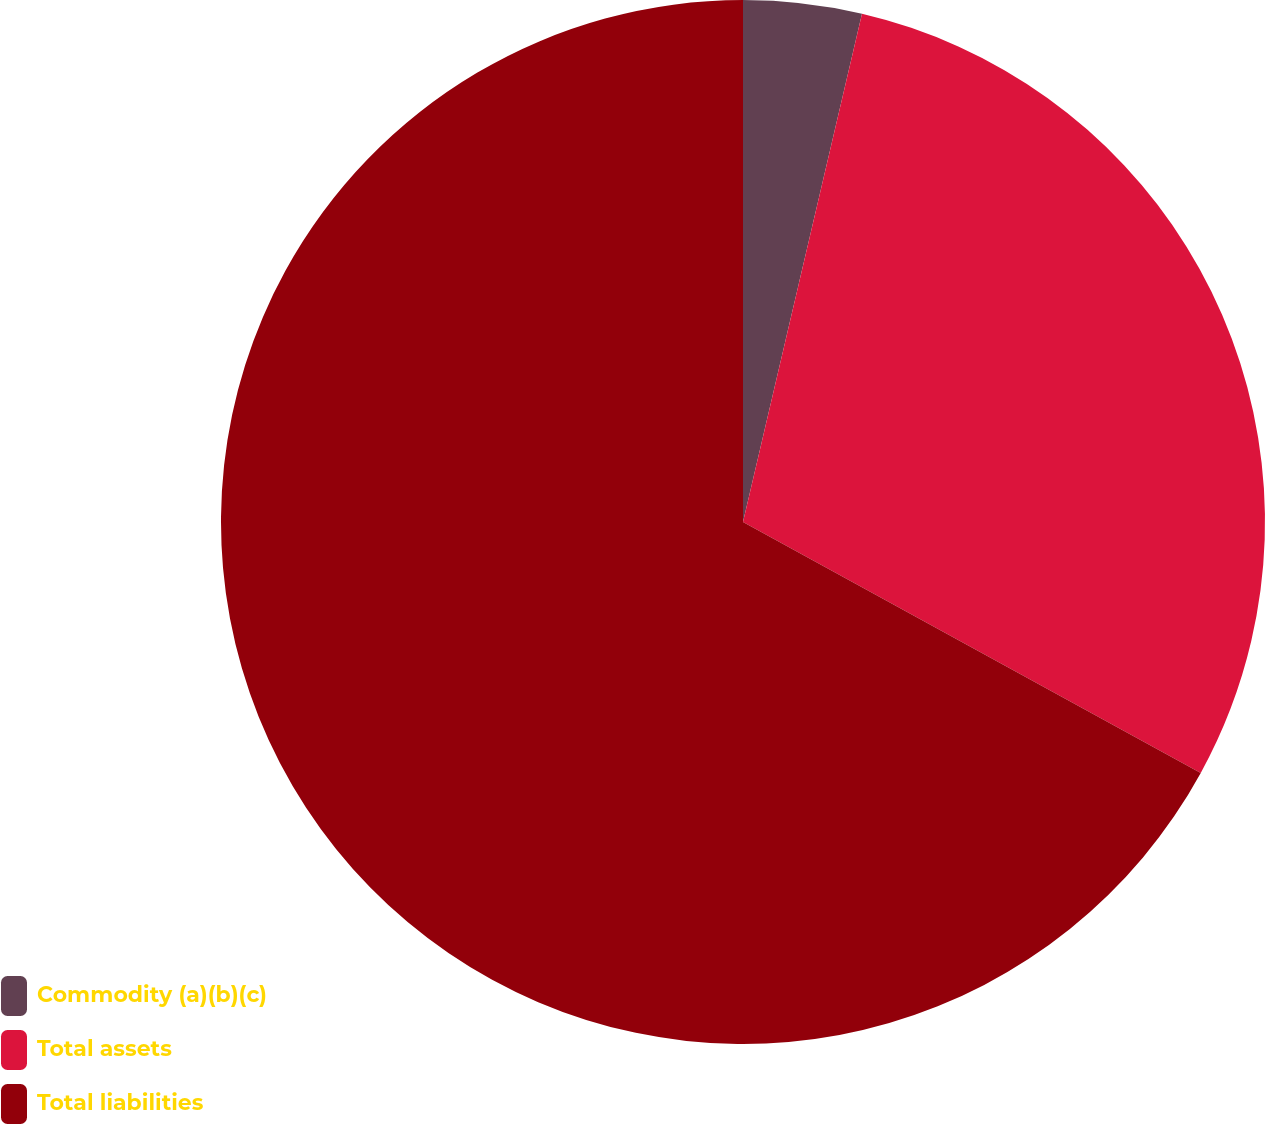Convert chart to OTSL. <chart><loc_0><loc_0><loc_500><loc_500><pie_chart><fcel>Commodity (a)(b)(c)<fcel>Total assets<fcel>Total liabilities<nl><fcel>3.66%<fcel>29.32%<fcel>67.02%<nl></chart> 